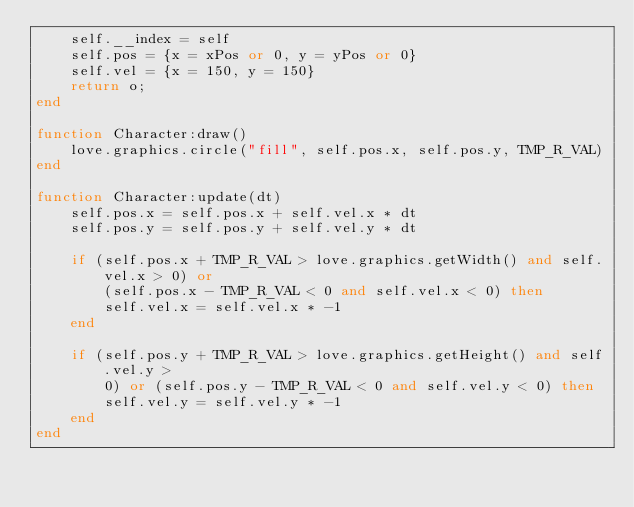Convert code to text. <code><loc_0><loc_0><loc_500><loc_500><_Lua_>    self.__index = self
    self.pos = {x = xPos or 0, y = yPos or 0}
    self.vel = {x = 150, y = 150}
    return o;
end

function Character:draw()
    love.graphics.circle("fill", self.pos.x, self.pos.y, TMP_R_VAL)
end

function Character:update(dt)
    self.pos.x = self.pos.x + self.vel.x * dt
    self.pos.y = self.pos.y + self.vel.y * dt

    if (self.pos.x + TMP_R_VAL > love.graphics.getWidth() and self.vel.x > 0) or
        (self.pos.x - TMP_R_VAL < 0 and self.vel.x < 0) then
        self.vel.x = self.vel.x * -1
    end

    if (self.pos.y + TMP_R_VAL > love.graphics.getHeight() and self.vel.y >
        0) or (self.pos.y - TMP_R_VAL < 0 and self.vel.y < 0) then
        self.vel.y = self.vel.y * -1
    end
end
</code> 